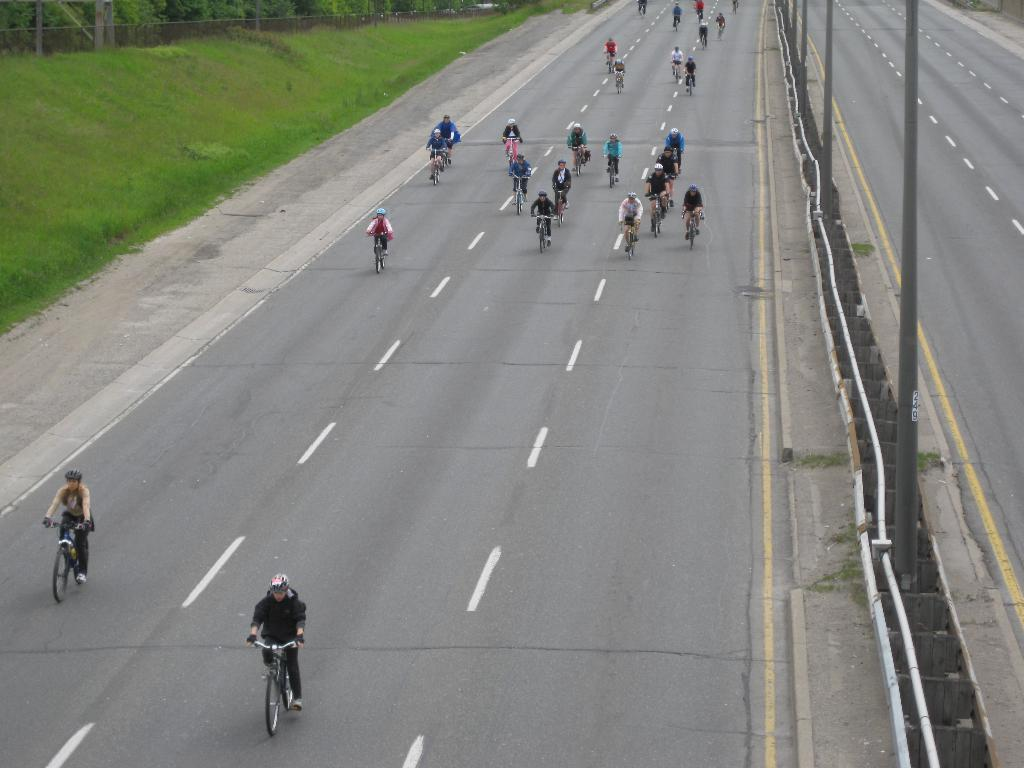What are the persons in the image doing? The persons in the image are riding bicycles on the road. What can be seen in the background of the image? In the background, there are street poles, pipelines, a footpath, grass, a fence, and trees. How many types of infrastructure are visible in the background? There are at least five types of infrastructure visible in the background: street poles, pipelines, a footpath, a fence, and trees. What type of oatmeal is being served on the road in the image? There is no oatmeal present in the image; the persons are riding bicycles on the road. What shape is the road in the image? The shape of the road cannot be determined from the image, as it is not visible in its entirety. 